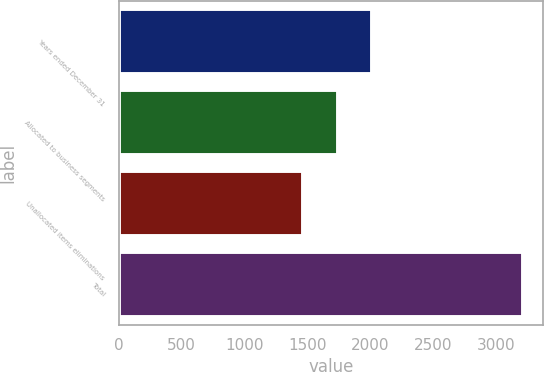Convert chart to OTSL. <chart><loc_0><loc_0><loc_500><loc_500><bar_chart><fcel>Years ended December 31<fcel>Allocated to business segments<fcel>Unallocated items eliminations<fcel>Total<nl><fcel>2014<fcel>1746<fcel>1469<fcel>3215<nl></chart> 